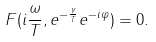Convert formula to latex. <formula><loc_0><loc_0><loc_500><loc_500>F ( i \frac { \omega } { T } , e ^ { - \frac { \gamma } { T } } e ^ { - i \varphi } ) = 0 .</formula> 